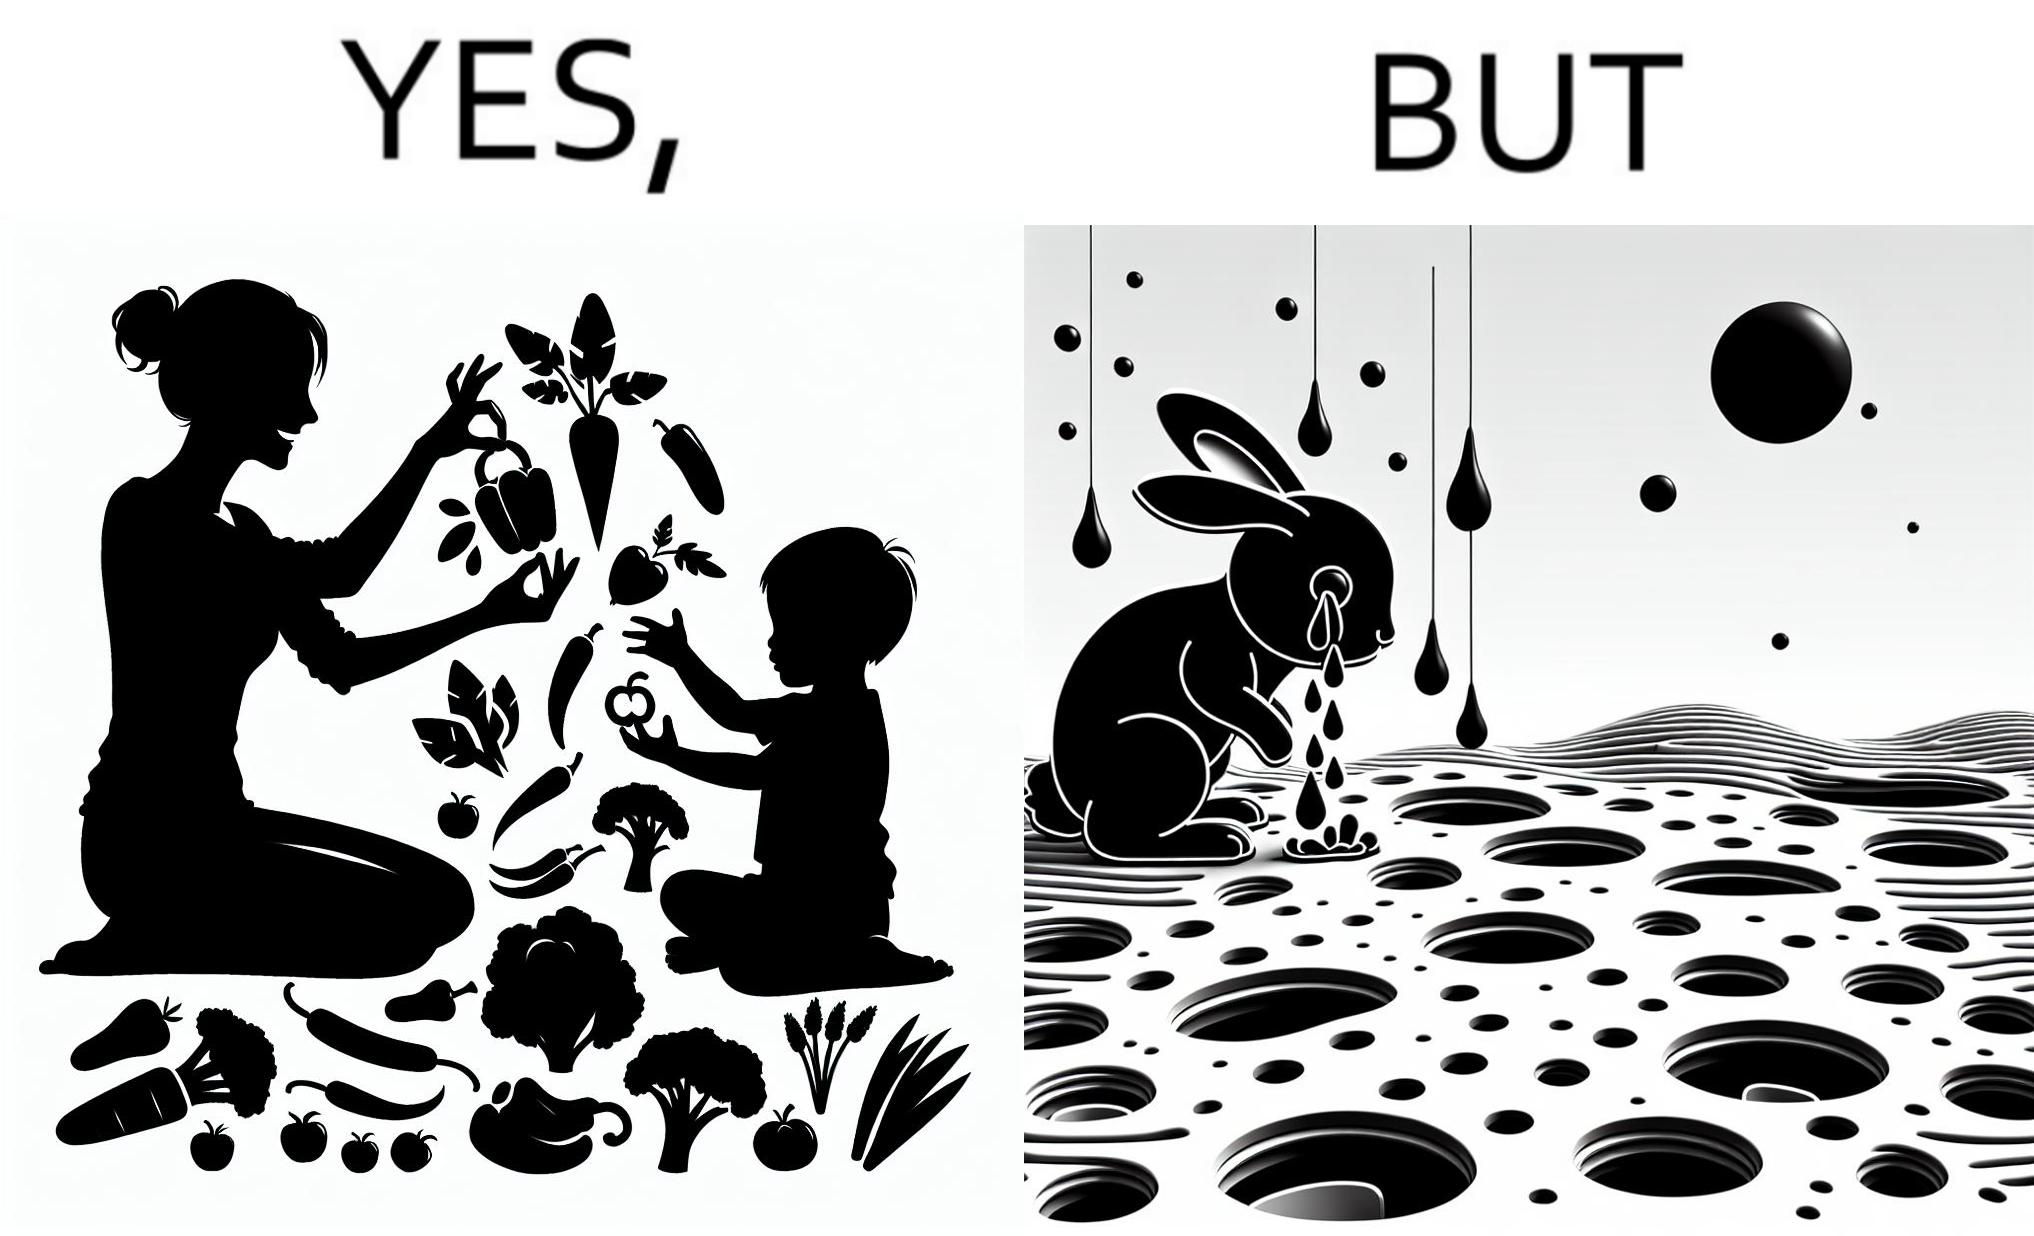Describe the content of this image. The images are ironic since they show how on one hand humans choose to play with and waste foods like vegetables while the animals are unable to eat enough food and end up starving due to lack of food 